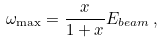<formula> <loc_0><loc_0><loc_500><loc_500>\omega _ { \max } = { \frac { x } { 1 + x } } E _ { b e a m } \, ,</formula> 